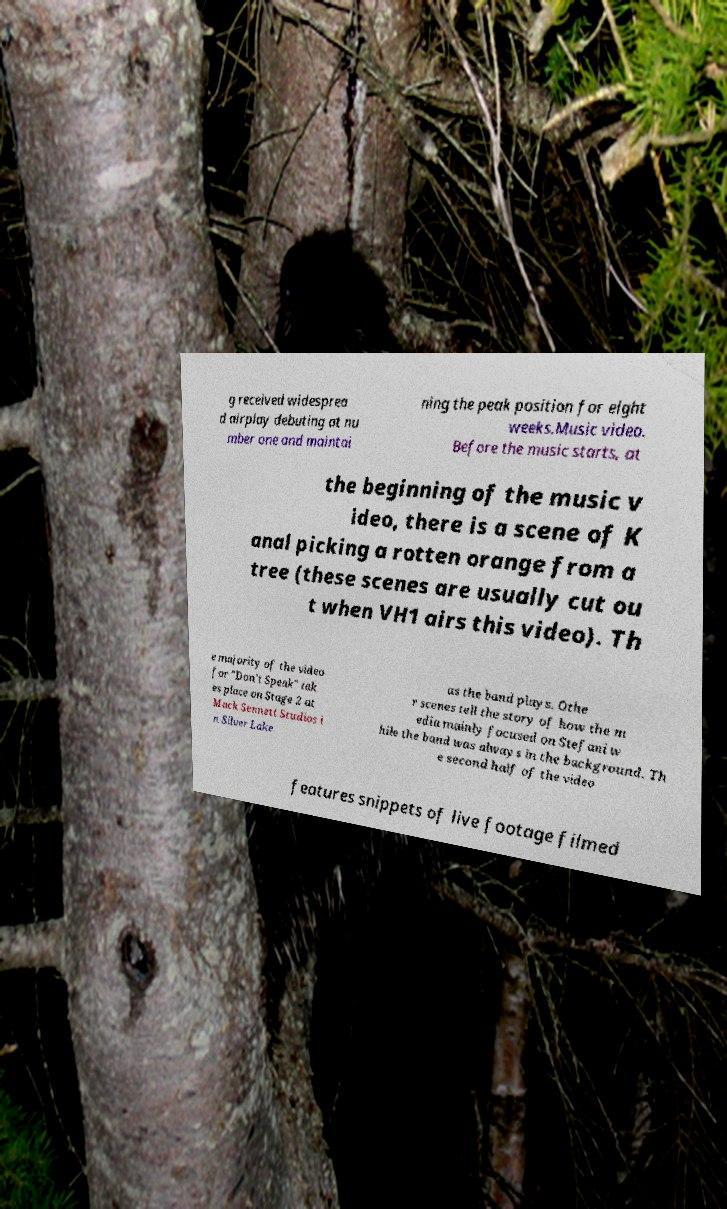Please identify and transcribe the text found in this image. g received widesprea d airplay debuting at nu mber one and maintai ning the peak position for eight weeks.Music video. Before the music starts, at the beginning of the music v ideo, there is a scene of K anal picking a rotten orange from a tree (these scenes are usually cut ou t when VH1 airs this video). Th e majority of the video for "Don't Speak" tak es place on Stage 2 at Mack Sennett Studios i n Silver Lake as the band plays. Othe r scenes tell the story of how the m edia mainly focused on Stefani w hile the band was always in the background. Th e second half of the video features snippets of live footage filmed 